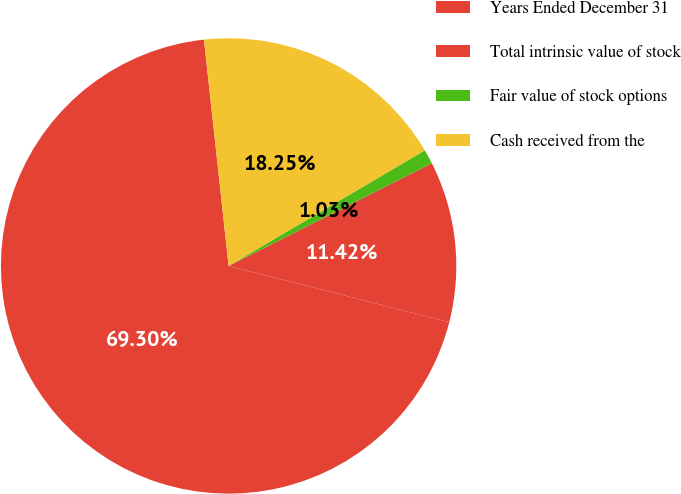<chart> <loc_0><loc_0><loc_500><loc_500><pie_chart><fcel>Years Ended December 31<fcel>Total intrinsic value of stock<fcel>Fair value of stock options<fcel>Cash received from the<nl><fcel>69.3%<fcel>11.42%<fcel>1.03%<fcel>18.25%<nl></chart> 